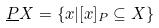Convert formula to latex. <formula><loc_0><loc_0><loc_500><loc_500>\underline { P } X = \{ x | [ x ] _ { P } \subseteq X \}</formula> 